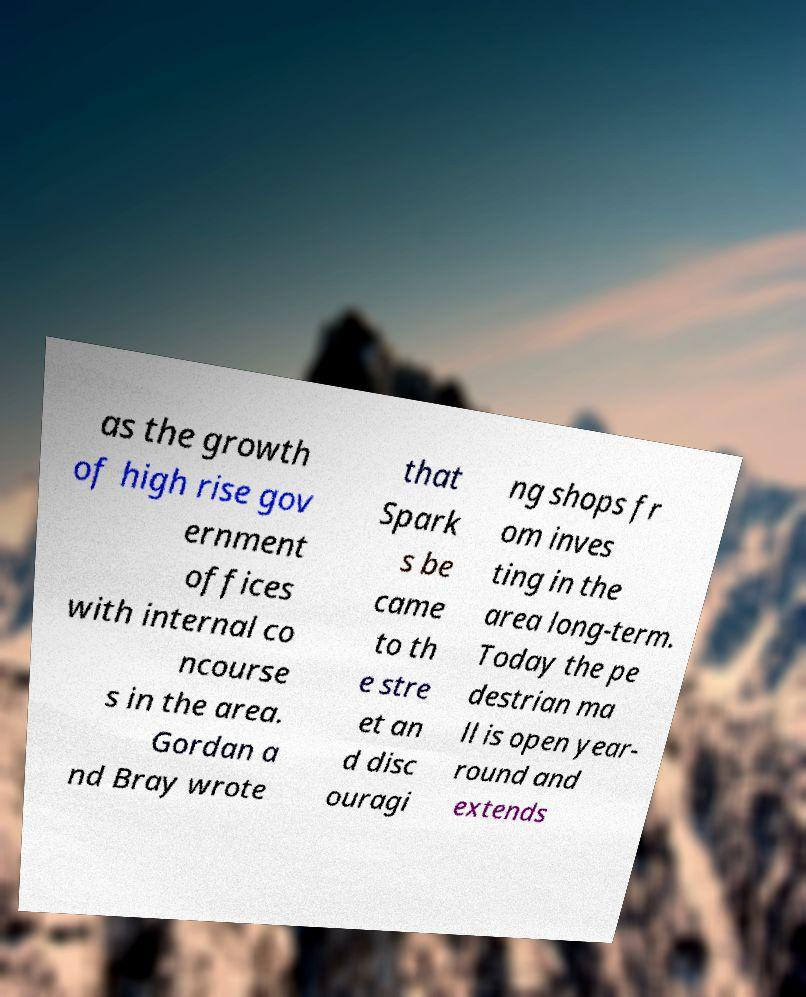For documentation purposes, I need the text within this image transcribed. Could you provide that? as the growth of high rise gov ernment offices with internal co ncourse s in the area. Gordan a nd Bray wrote that Spark s be came to th e stre et an d disc ouragi ng shops fr om inves ting in the area long-term. Today the pe destrian ma ll is open year- round and extends 